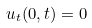<formula> <loc_0><loc_0><loc_500><loc_500>u _ { t } ( 0 , t ) = 0</formula> 